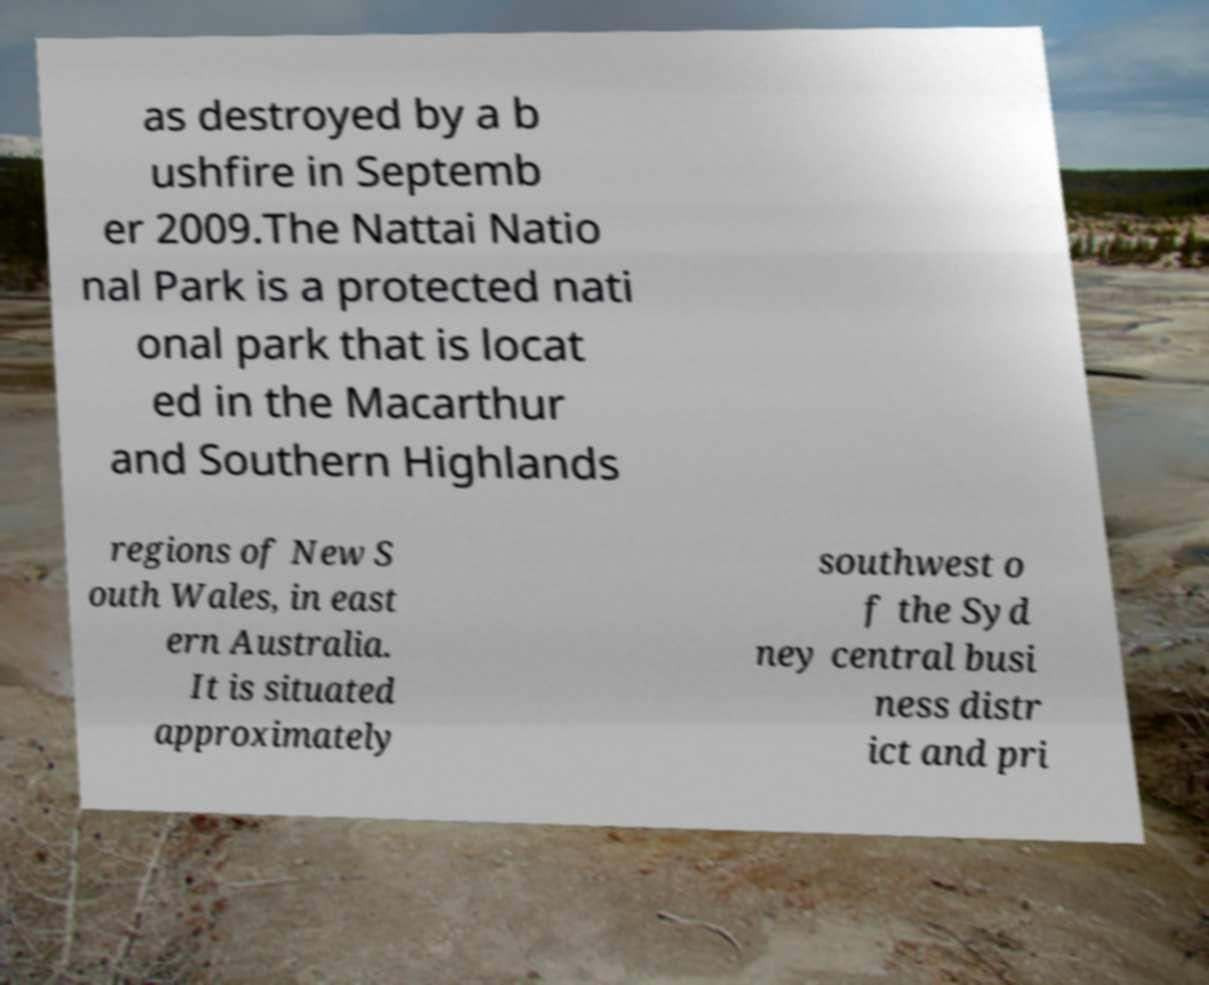There's text embedded in this image that I need extracted. Can you transcribe it verbatim? as destroyed by a b ushfire in Septemb er 2009.The Nattai Natio nal Park is a protected nati onal park that is locat ed in the Macarthur and Southern Highlands regions of New S outh Wales, in east ern Australia. It is situated approximately southwest o f the Syd ney central busi ness distr ict and pri 